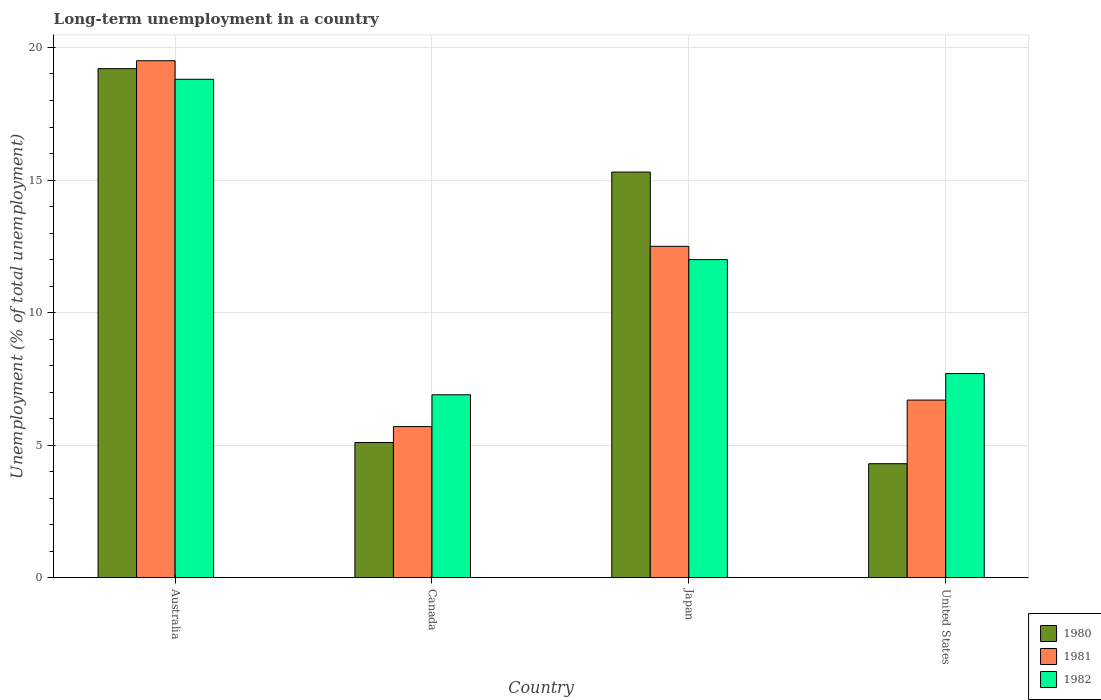How many different coloured bars are there?
Ensure brevity in your answer.  3. Are the number of bars per tick equal to the number of legend labels?
Offer a very short reply. Yes. Are the number of bars on each tick of the X-axis equal?
Offer a very short reply. Yes. How many bars are there on the 3rd tick from the left?
Keep it short and to the point. 3. What is the label of the 4th group of bars from the left?
Keep it short and to the point. United States. In how many cases, is the number of bars for a given country not equal to the number of legend labels?
Ensure brevity in your answer.  0. What is the percentage of long-term unemployed population in 1980 in Australia?
Keep it short and to the point. 19.2. Across all countries, what is the minimum percentage of long-term unemployed population in 1981?
Ensure brevity in your answer.  5.7. In which country was the percentage of long-term unemployed population in 1981 minimum?
Your response must be concise. Canada. What is the total percentage of long-term unemployed population in 1980 in the graph?
Your response must be concise. 43.9. What is the difference between the percentage of long-term unemployed population in 1982 in Japan and that in United States?
Your answer should be very brief. 4.3. What is the difference between the percentage of long-term unemployed population in 1981 in Japan and the percentage of long-term unemployed population in 1982 in Canada?
Provide a succinct answer. 5.6. What is the average percentage of long-term unemployed population in 1981 per country?
Offer a very short reply. 11.1. What is the difference between the percentage of long-term unemployed population of/in 1982 and percentage of long-term unemployed population of/in 1980 in Australia?
Your answer should be compact. -0.4. In how many countries, is the percentage of long-term unemployed population in 1982 greater than 9 %?
Your answer should be very brief. 2. What is the ratio of the percentage of long-term unemployed population in 1981 in Australia to that in Canada?
Provide a succinct answer. 3.42. What is the difference between the highest and the second highest percentage of long-term unemployed population in 1982?
Your answer should be compact. 6.8. What is the difference between the highest and the lowest percentage of long-term unemployed population in 1980?
Make the answer very short. 14.9. In how many countries, is the percentage of long-term unemployed population in 1980 greater than the average percentage of long-term unemployed population in 1980 taken over all countries?
Your answer should be compact. 2. What does the 3rd bar from the left in United States represents?
Give a very brief answer. 1982. How many countries are there in the graph?
Your response must be concise. 4. Are the values on the major ticks of Y-axis written in scientific E-notation?
Give a very brief answer. No. Does the graph contain any zero values?
Your answer should be very brief. No. Does the graph contain grids?
Keep it short and to the point. Yes. Where does the legend appear in the graph?
Your answer should be very brief. Bottom right. How many legend labels are there?
Make the answer very short. 3. What is the title of the graph?
Ensure brevity in your answer.  Long-term unemployment in a country. What is the label or title of the Y-axis?
Your response must be concise. Unemployment (% of total unemployment). What is the Unemployment (% of total unemployment) in 1980 in Australia?
Offer a terse response. 19.2. What is the Unemployment (% of total unemployment) of 1981 in Australia?
Your answer should be compact. 19.5. What is the Unemployment (% of total unemployment) of 1982 in Australia?
Offer a very short reply. 18.8. What is the Unemployment (% of total unemployment) of 1980 in Canada?
Provide a succinct answer. 5.1. What is the Unemployment (% of total unemployment) of 1981 in Canada?
Your response must be concise. 5.7. What is the Unemployment (% of total unemployment) of 1982 in Canada?
Make the answer very short. 6.9. What is the Unemployment (% of total unemployment) of 1980 in Japan?
Keep it short and to the point. 15.3. What is the Unemployment (% of total unemployment) of 1980 in United States?
Provide a short and direct response. 4.3. What is the Unemployment (% of total unemployment) in 1981 in United States?
Provide a succinct answer. 6.7. What is the Unemployment (% of total unemployment) in 1982 in United States?
Make the answer very short. 7.7. Across all countries, what is the maximum Unemployment (% of total unemployment) in 1980?
Offer a very short reply. 19.2. Across all countries, what is the maximum Unemployment (% of total unemployment) of 1981?
Your answer should be very brief. 19.5. Across all countries, what is the maximum Unemployment (% of total unemployment) of 1982?
Your answer should be compact. 18.8. Across all countries, what is the minimum Unemployment (% of total unemployment) in 1980?
Offer a very short reply. 4.3. Across all countries, what is the minimum Unemployment (% of total unemployment) of 1981?
Offer a very short reply. 5.7. Across all countries, what is the minimum Unemployment (% of total unemployment) of 1982?
Provide a short and direct response. 6.9. What is the total Unemployment (% of total unemployment) of 1980 in the graph?
Your response must be concise. 43.9. What is the total Unemployment (% of total unemployment) of 1981 in the graph?
Provide a short and direct response. 44.4. What is the total Unemployment (% of total unemployment) of 1982 in the graph?
Your answer should be compact. 45.4. What is the difference between the Unemployment (% of total unemployment) of 1981 in Australia and that in Canada?
Make the answer very short. 13.8. What is the difference between the Unemployment (% of total unemployment) in 1982 in Australia and that in Canada?
Offer a terse response. 11.9. What is the difference between the Unemployment (% of total unemployment) of 1980 in Australia and that in Japan?
Ensure brevity in your answer.  3.9. What is the difference between the Unemployment (% of total unemployment) of 1981 in Australia and that in Japan?
Offer a very short reply. 7. What is the difference between the Unemployment (% of total unemployment) of 1982 in Australia and that in Japan?
Offer a very short reply. 6.8. What is the difference between the Unemployment (% of total unemployment) of 1981 in Canada and that in Japan?
Provide a short and direct response. -6.8. What is the difference between the Unemployment (% of total unemployment) in 1981 in Canada and that in United States?
Your answer should be compact. -1. What is the difference between the Unemployment (% of total unemployment) in 1982 in Canada and that in United States?
Offer a very short reply. -0.8. What is the difference between the Unemployment (% of total unemployment) in 1982 in Japan and that in United States?
Your answer should be very brief. 4.3. What is the difference between the Unemployment (% of total unemployment) in 1980 in Australia and the Unemployment (% of total unemployment) in 1981 in Canada?
Your answer should be compact. 13.5. What is the difference between the Unemployment (% of total unemployment) in 1981 in Australia and the Unemployment (% of total unemployment) in 1982 in Canada?
Offer a very short reply. 12.6. What is the difference between the Unemployment (% of total unemployment) of 1981 in Australia and the Unemployment (% of total unemployment) of 1982 in Japan?
Your answer should be compact. 7.5. What is the difference between the Unemployment (% of total unemployment) of 1981 in Australia and the Unemployment (% of total unemployment) of 1982 in United States?
Ensure brevity in your answer.  11.8. What is the difference between the Unemployment (% of total unemployment) in 1980 in Canada and the Unemployment (% of total unemployment) in 1981 in United States?
Your response must be concise. -1.6. What is the difference between the Unemployment (% of total unemployment) in 1980 in Canada and the Unemployment (% of total unemployment) in 1982 in United States?
Give a very brief answer. -2.6. What is the difference between the Unemployment (% of total unemployment) in 1980 in Japan and the Unemployment (% of total unemployment) in 1981 in United States?
Your answer should be very brief. 8.6. What is the difference between the Unemployment (% of total unemployment) in 1981 in Japan and the Unemployment (% of total unemployment) in 1982 in United States?
Keep it short and to the point. 4.8. What is the average Unemployment (% of total unemployment) in 1980 per country?
Provide a succinct answer. 10.97. What is the average Unemployment (% of total unemployment) of 1981 per country?
Your response must be concise. 11.1. What is the average Unemployment (% of total unemployment) of 1982 per country?
Offer a very short reply. 11.35. What is the difference between the Unemployment (% of total unemployment) in 1980 and Unemployment (% of total unemployment) in 1981 in Canada?
Make the answer very short. -0.6. What is the difference between the Unemployment (% of total unemployment) of 1981 and Unemployment (% of total unemployment) of 1982 in Canada?
Provide a short and direct response. -1.2. What is the difference between the Unemployment (% of total unemployment) in 1980 and Unemployment (% of total unemployment) in 1981 in Japan?
Offer a terse response. 2.8. What is the difference between the Unemployment (% of total unemployment) in 1980 and Unemployment (% of total unemployment) in 1981 in United States?
Ensure brevity in your answer.  -2.4. What is the ratio of the Unemployment (% of total unemployment) in 1980 in Australia to that in Canada?
Your answer should be compact. 3.76. What is the ratio of the Unemployment (% of total unemployment) in 1981 in Australia to that in Canada?
Provide a succinct answer. 3.42. What is the ratio of the Unemployment (% of total unemployment) of 1982 in Australia to that in Canada?
Give a very brief answer. 2.72. What is the ratio of the Unemployment (% of total unemployment) in 1980 in Australia to that in Japan?
Your answer should be very brief. 1.25. What is the ratio of the Unemployment (% of total unemployment) of 1981 in Australia to that in Japan?
Provide a succinct answer. 1.56. What is the ratio of the Unemployment (% of total unemployment) in 1982 in Australia to that in Japan?
Your answer should be compact. 1.57. What is the ratio of the Unemployment (% of total unemployment) in 1980 in Australia to that in United States?
Offer a terse response. 4.47. What is the ratio of the Unemployment (% of total unemployment) of 1981 in Australia to that in United States?
Your response must be concise. 2.91. What is the ratio of the Unemployment (% of total unemployment) in 1982 in Australia to that in United States?
Your response must be concise. 2.44. What is the ratio of the Unemployment (% of total unemployment) of 1980 in Canada to that in Japan?
Ensure brevity in your answer.  0.33. What is the ratio of the Unemployment (% of total unemployment) of 1981 in Canada to that in Japan?
Make the answer very short. 0.46. What is the ratio of the Unemployment (% of total unemployment) of 1982 in Canada to that in Japan?
Offer a very short reply. 0.57. What is the ratio of the Unemployment (% of total unemployment) in 1980 in Canada to that in United States?
Offer a terse response. 1.19. What is the ratio of the Unemployment (% of total unemployment) in 1981 in Canada to that in United States?
Offer a terse response. 0.85. What is the ratio of the Unemployment (% of total unemployment) of 1982 in Canada to that in United States?
Give a very brief answer. 0.9. What is the ratio of the Unemployment (% of total unemployment) of 1980 in Japan to that in United States?
Your answer should be very brief. 3.56. What is the ratio of the Unemployment (% of total unemployment) in 1981 in Japan to that in United States?
Offer a terse response. 1.87. What is the ratio of the Unemployment (% of total unemployment) in 1982 in Japan to that in United States?
Make the answer very short. 1.56. What is the difference between the highest and the second highest Unemployment (% of total unemployment) in 1980?
Ensure brevity in your answer.  3.9. What is the difference between the highest and the lowest Unemployment (% of total unemployment) in 1981?
Keep it short and to the point. 13.8. 